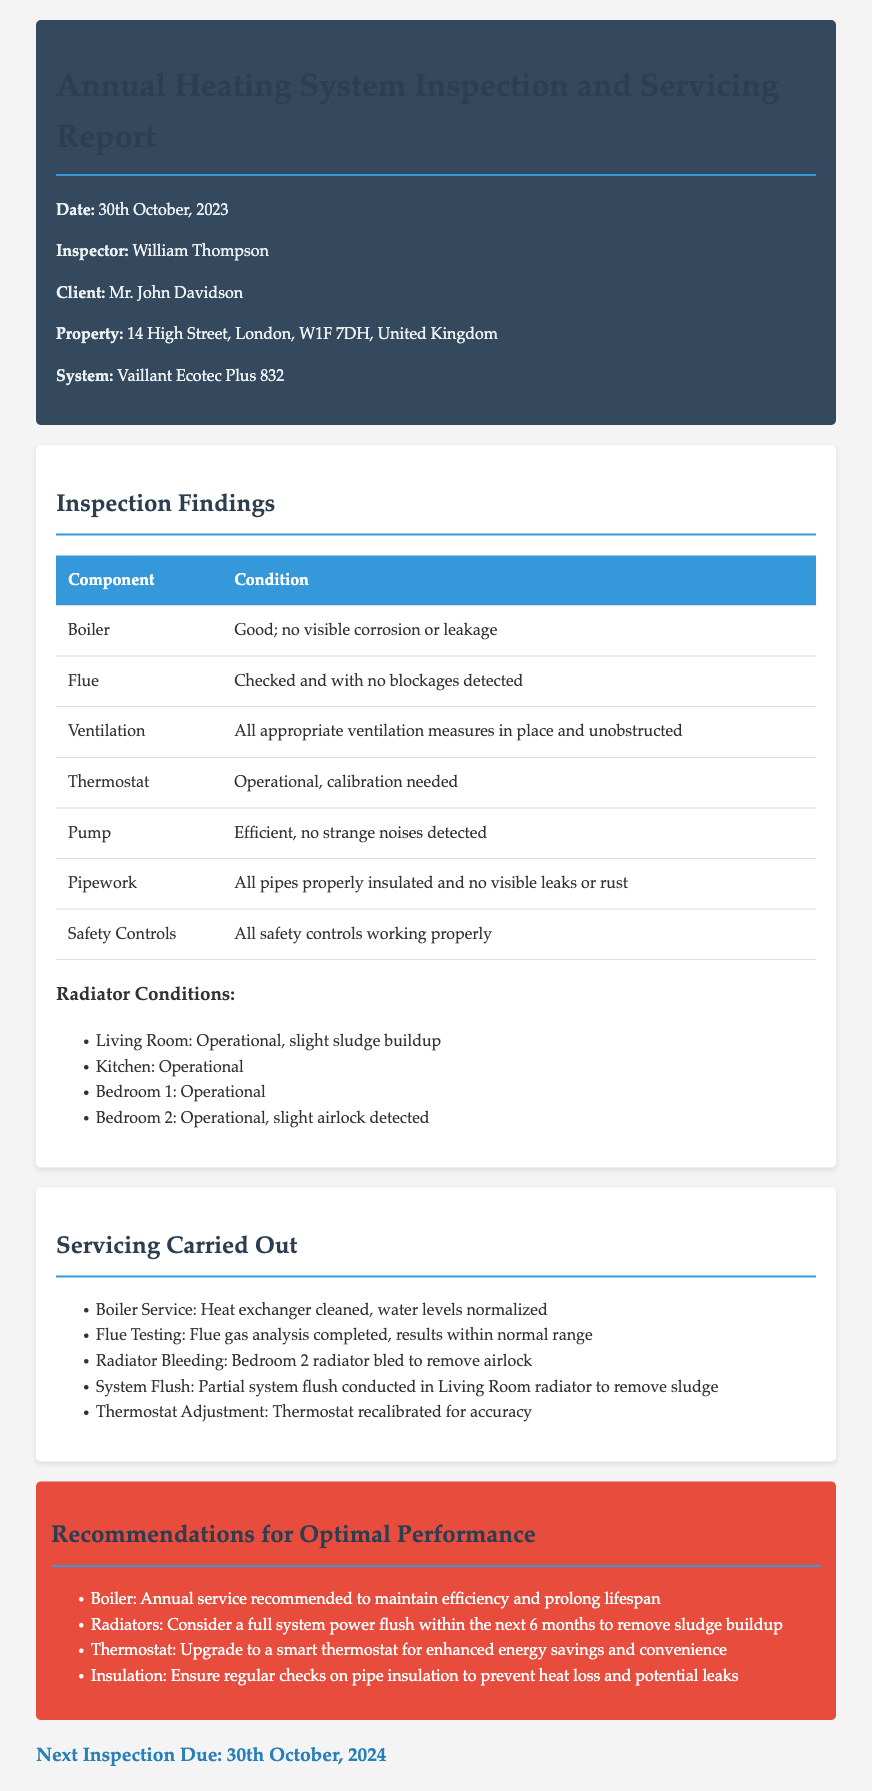what is the date of the inspection? The date of the inspection is mentioned at the beginning of the report.
Answer: 30th October, 2023 who is the inspector? The inspector's name is provided in the header section of the report.
Answer: William Thompson what system was inspected? The type of heating system inspected is stated in the header.
Answer: Vaillant Ecotec Plus 832 what was the condition of the boiler? The condition of the boiler is specified in the inspection findings section.
Answer: Good; no visible corrosion or leakage what recommendations were made regarding the radiators? The recommendations about the radiators can be found in the recommendations section.
Answer: Consider a full system power flush within the next 6 months to remove sludge buildup what action was taken for the thermostat during servicing? The action taken regarding the thermostat is listed in the servicing carried out section.
Answer: Thermostat recalibrated for accuracy how often is a boiler service recommended? The frequency of the recommended boiler service is mentioned in the recommendations section.
Answer: Annual service recommended what issue was detected in Bedroom 2 radiator? The specific issue found in Bedroom 2 radiator is detailed in the inspection findings.
Answer: slight airlock detected when is the next inspection due? The due date for the next inspection is stated towards the end of the report.
Answer: 30th October, 2024 